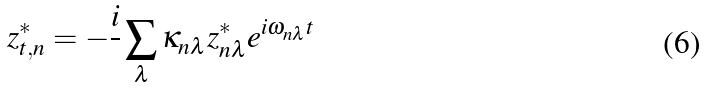<formula> <loc_0><loc_0><loc_500><loc_500>z ^ { * } _ { t , n } = - \frac { i } { } \sum _ { \lambda } \kappa _ { n \lambda } z ^ { * } _ { n \lambda } e ^ { i \omega _ { n \lambda } t }</formula> 